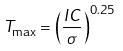<formula> <loc_0><loc_0><loc_500><loc_500>T _ { \max } = \left ( { \frac { I C } { \sigma } } \right ) ^ { 0 . 2 5 }</formula> 